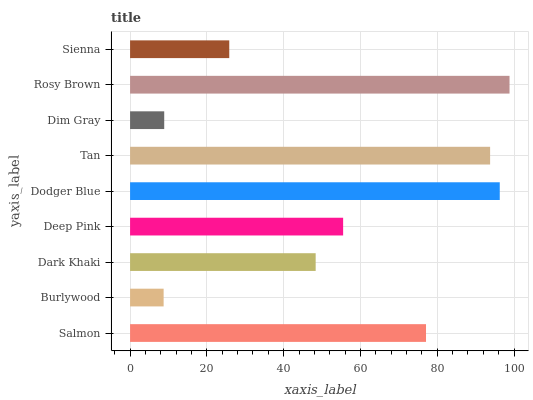Is Burlywood the minimum?
Answer yes or no. Yes. Is Rosy Brown the maximum?
Answer yes or no. Yes. Is Dark Khaki the minimum?
Answer yes or no. No. Is Dark Khaki the maximum?
Answer yes or no. No. Is Dark Khaki greater than Burlywood?
Answer yes or no. Yes. Is Burlywood less than Dark Khaki?
Answer yes or no. Yes. Is Burlywood greater than Dark Khaki?
Answer yes or no. No. Is Dark Khaki less than Burlywood?
Answer yes or no. No. Is Deep Pink the high median?
Answer yes or no. Yes. Is Deep Pink the low median?
Answer yes or no. Yes. Is Dim Gray the high median?
Answer yes or no. No. Is Sienna the low median?
Answer yes or no. No. 